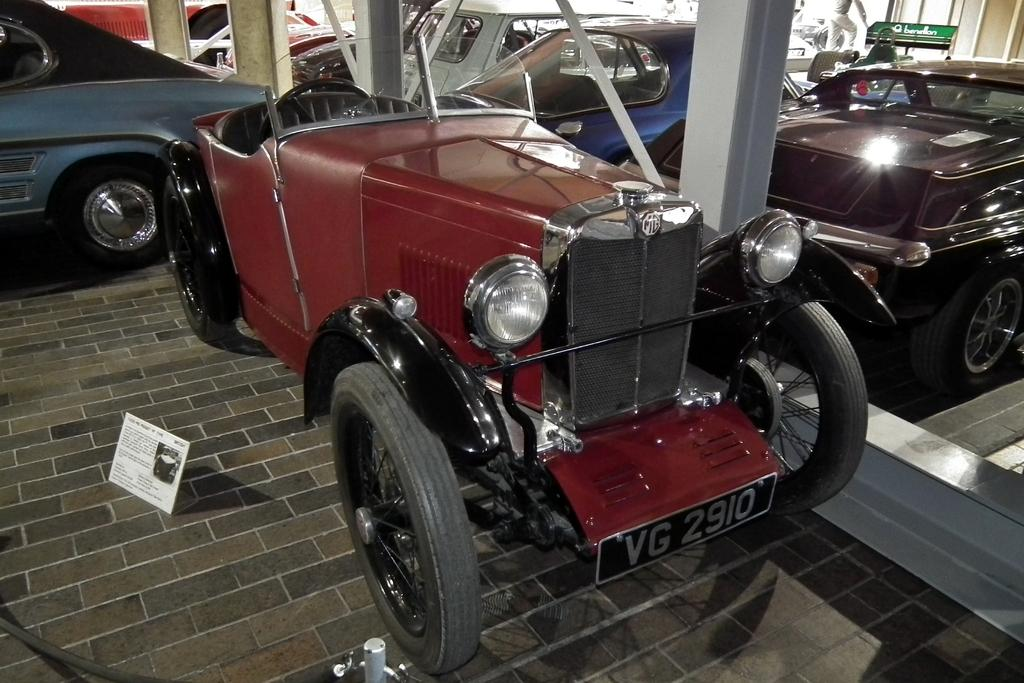<image>
Write a terse but informative summary of the picture. A green Benellon bench sits in the back of an old car show. 